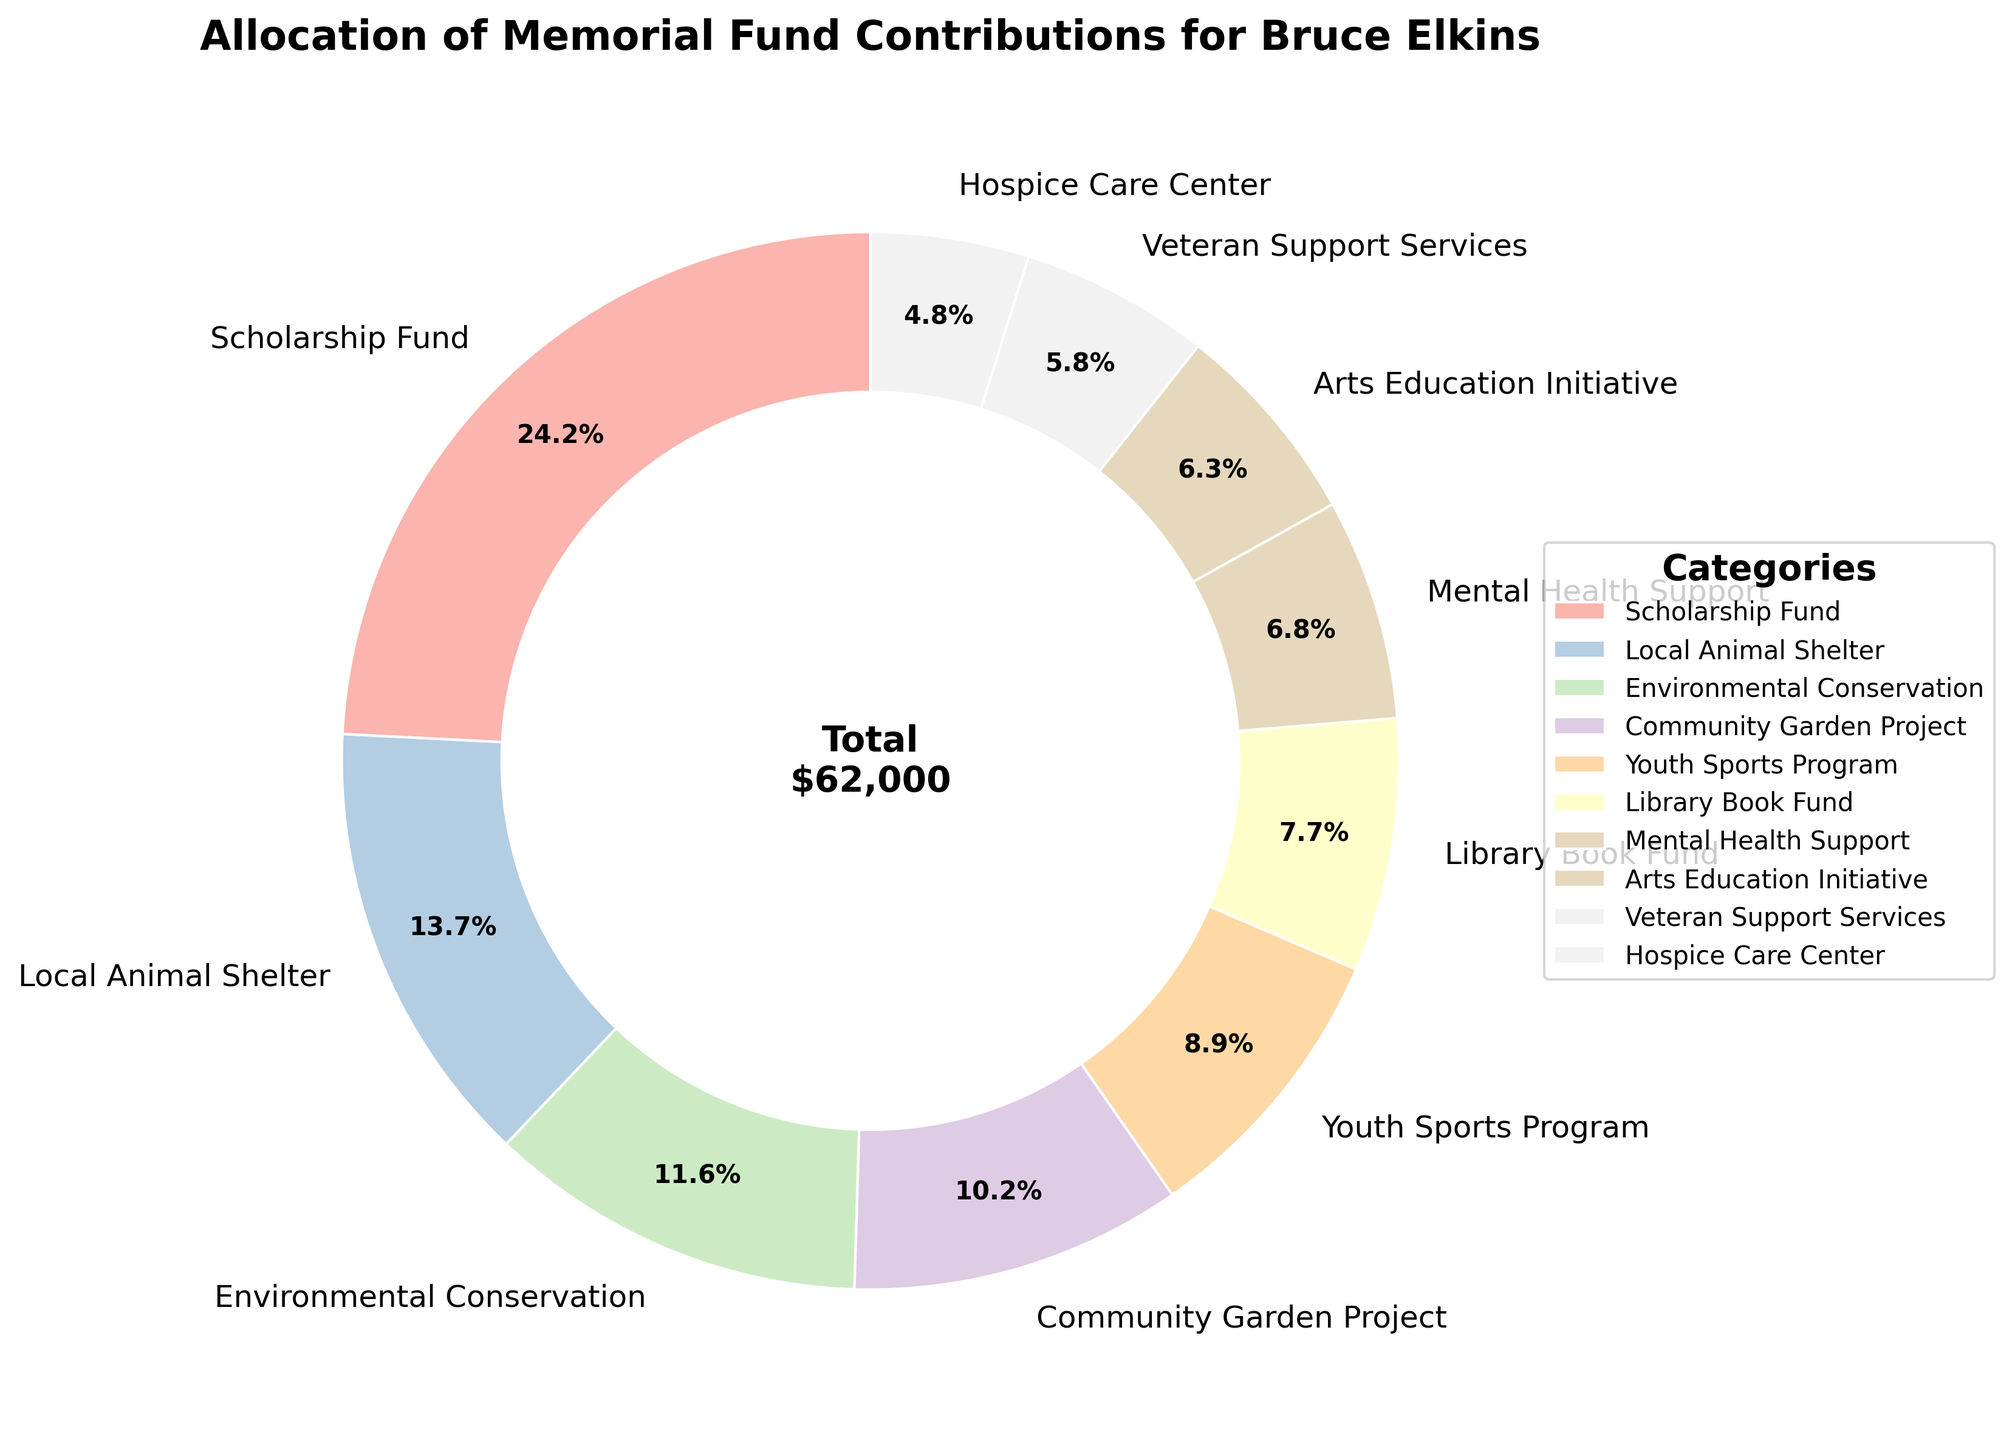What is the total amount allocated to Mental Health Support and Hospice Care Center combined? First, locate the amounts for Mental Health Support ($4,200) and Hospice Care Center ($3,000). Add them together: $4,200 + $3,000 = $7,200.
Answer: $7,200 Which category received the highest amount of contributions? Look at the pie chart and identify which category has the largest portion. The Scholarship Fund received $15,000, which is the highest.
Answer: Scholarship Fund How much more was allocated to the Scholarship Fund than to the Community Garden Project? Identify the amounts allocated to both categories. The Scholarship Fund has $15,000, and the Community Garden Project has $6,300. Subtract the latter from the former: $15,000 - $6,300 = $8,700.
Answer: $8,700 Which categories have allocations greater than $7,000? Refer to the pie chart sections that represent amounts over $7,000. The Scholarship Fund ($15,000), Local Animal Shelter ($8,500), and Environmental Conservation ($7,200) meet this criterion.
Answer: Scholarship Fund, Local Animal Shelter, Environmental Conservation What is the sum of contributions to categories involving children (Scholarship Fund and Youth Sports Program)? Identify the amounts allocated: Scholarship Fund ($15,000) and Youth Sports Program ($5,500). Add them together: $15,000 + $5,500 = $20,500.
Answer: $20,500 Which category has the smallest allocation, and what is its amount? Look at the pie chart to find the smallest portion. Hospice Care Center has the smallest allocation of $3,000.
Answer: Hospice Care Center, $3,000 Compare the allocation between Arts Education Initiative and Veteran Support Services. Which one has more and by how much? Look at the amounts: Arts Education Initiative ($3,900) and Veteran Support Services ($3,600). Subtract $3,600 from $3,900: $3,900 - $3,600 = $300.
Answer: Arts Education Initiative has more by $300 What percentage of the total fund goes towards the Environmental Conservation category? Identify the amount for Environmental Conservation ($7,200). Then, calculate the percentage of this amount relative to the total fund ($59,000). ($7,200 / $59,000) * 100 = 12.2%.
Answer: 12.2% If the contributions to the Library Book Fund were doubled, how would it compare to the contributions for the Local Animal Shelter? First, double the Library Book Fund amount: $4,800 * 2 = $9,600. Then compare it with the Local Animal Shelter: $9,600 - $8,500 = $1,100 more.
Answer: $1,100 more 